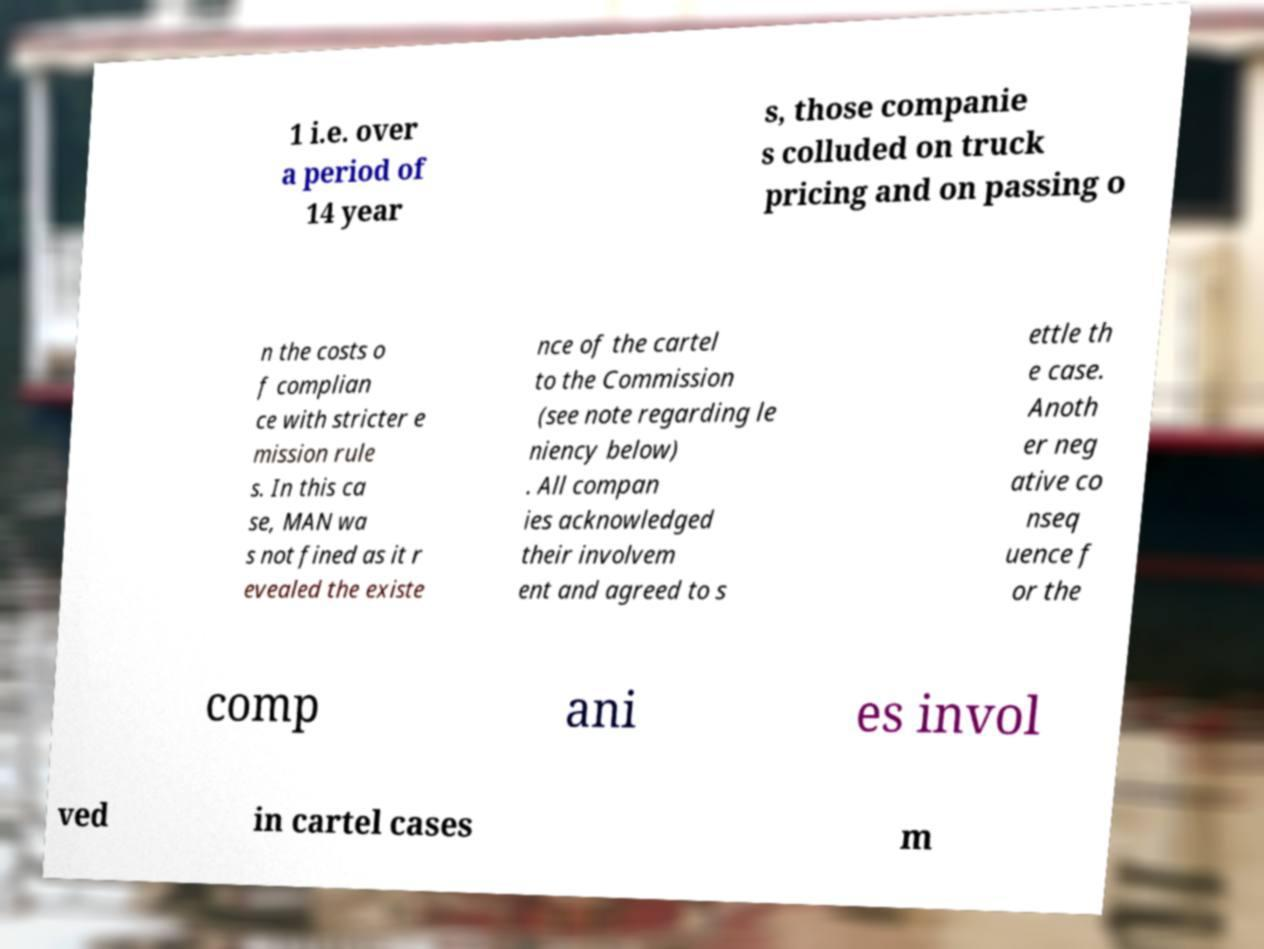Could you assist in decoding the text presented in this image and type it out clearly? 1 i.e. over a period of 14 year s, those companie s colluded on truck pricing and on passing o n the costs o f complian ce with stricter e mission rule s. In this ca se, MAN wa s not fined as it r evealed the existe nce of the cartel to the Commission (see note regarding le niency below) . All compan ies acknowledged their involvem ent and agreed to s ettle th e case. Anoth er neg ative co nseq uence f or the comp ani es invol ved in cartel cases m 